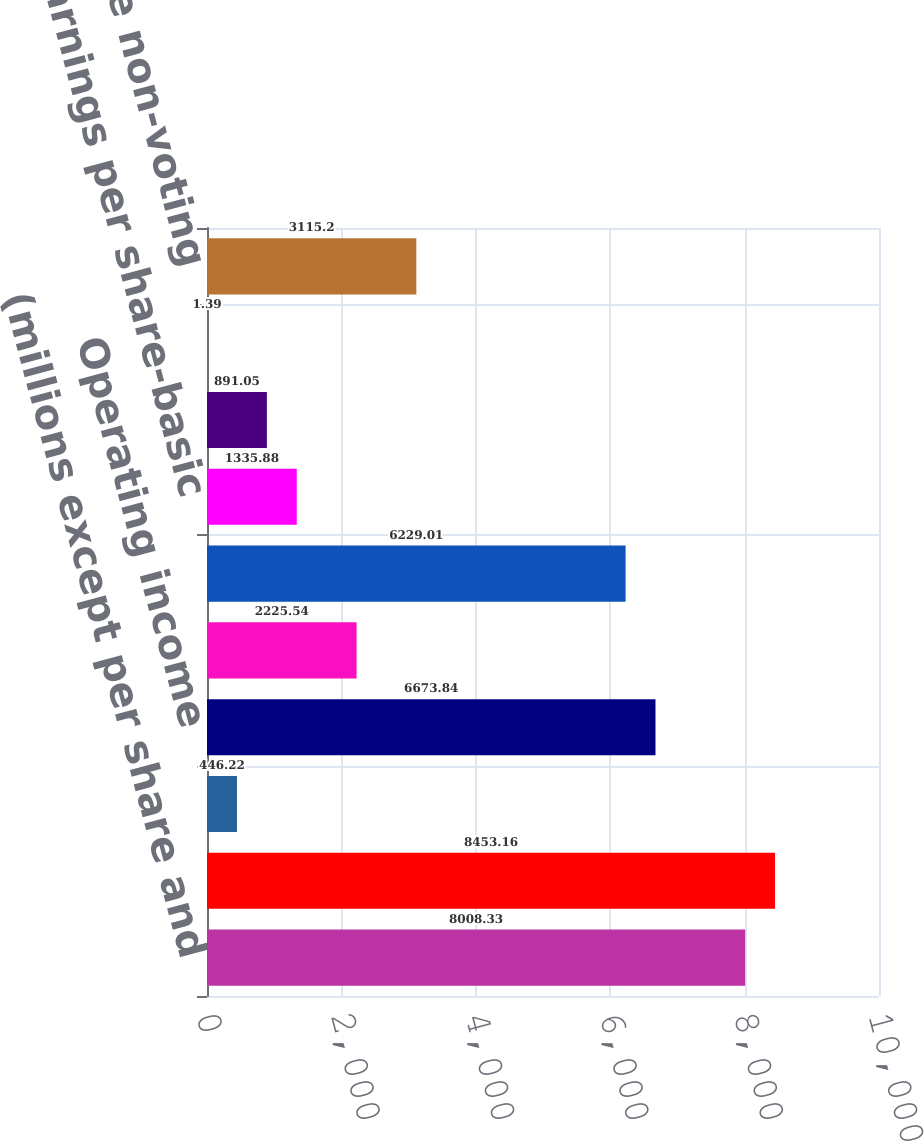Convert chart. <chart><loc_0><loc_0><loc_500><loc_500><bar_chart><fcel>(millions except per share and<fcel>Net sales<fcel>Percent increase<fcel>Operating income<fcel>Income from unconsolidated<fcel>Net income<fcel>Earnings per share-basic<fcel>Earnings per share-diluted<fcel>Common dividends declared<fcel>Closing price non-voting<nl><fcel>8008.33<fcel>8453.16<fcel>446.22<fcel>6673.84<fcel>2225.54<fcel>6229.01<fcel>1335.88<fcel>891.05<fcel>1.39<fcel>3115.2<nl></chart> 